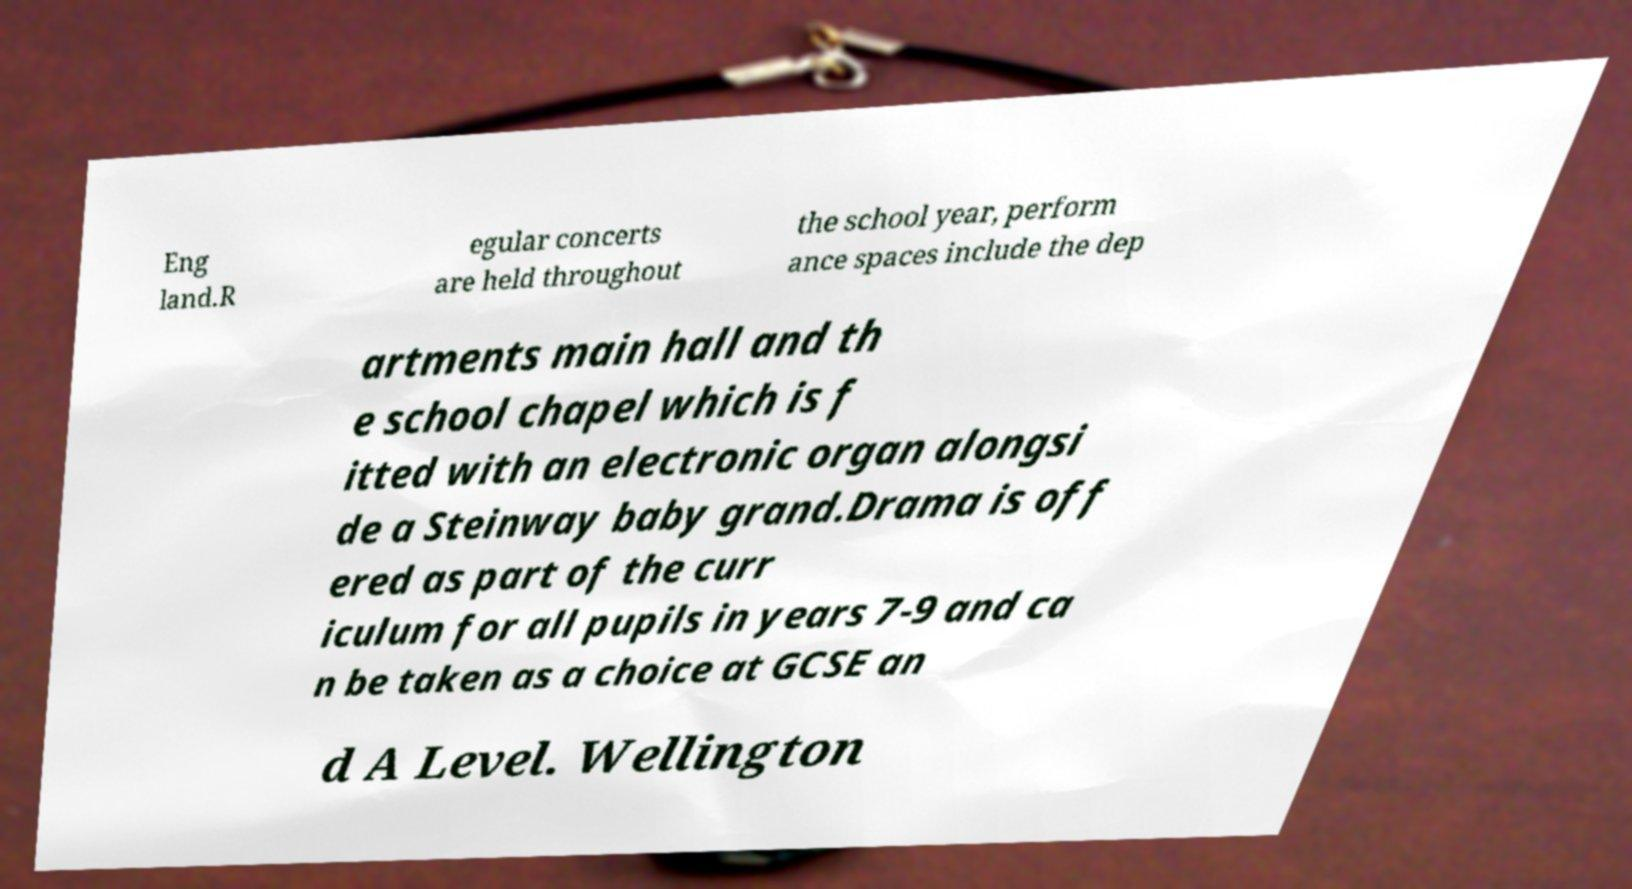Please identify and transcribe the text found in this image. Eng land.R egular concerts are held throughout the school year, perform ance spaces include the dep artments main hall and th e school chapel which is f itted with an electronic organ alongsi de a Steinway baby grand.Drama is off ered as part of the curr iculum for all pupils in years 7-9 and ca n be taken as a choice at GCSE an d A Level. Wellington 